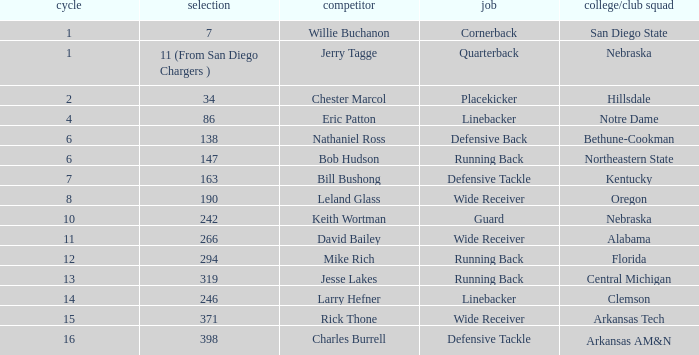Which player is it that has a pick of 147? Bob Hudson. 